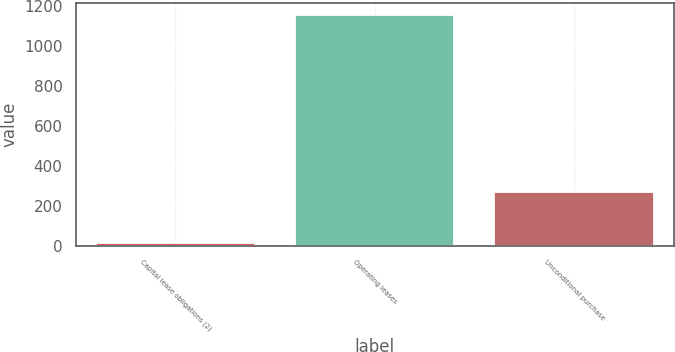Convert chart. <chart><loc_0><loc_0><loc_500><loc_500><bar_chart><fcel>Capital lease obligations (2)<fcel>Operating leases<fcel>Unconditional purchase<nl><fcel>11<fcel>1155<fcel>268<nl></chart> 